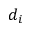Convert formula to latex. <formula><loc_0><loc_0><loc_500><loc_500>d _ { i }</formula> 